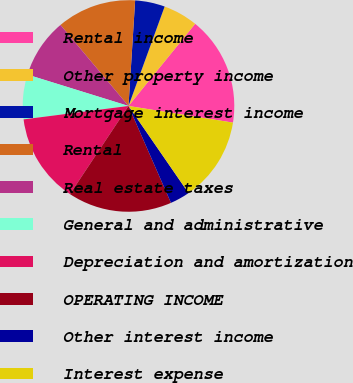Convert chart. <chart><loc_0><loc_0><loc_500><loc_500><pie_chart><fcel>Rental income<fcel>Other property income<fcel>Mortgage interest income<fcel>Rental<fcel>Real estate taxes<fcel>General and administrative<fcel>Depreciation and amortization<fcel>OPERATING INCOME<fcel>Other interest income<fcel>Interest expense<nl><fcel>16.67%<fcel>5.3%<fcel>4.55%<fcel>12.12%<fcel>9.09%<fcel>6.82%<fcel>13.64%<fcel>15.91%<fcel>3.03%<fcel>12.88%<nl></chart> 